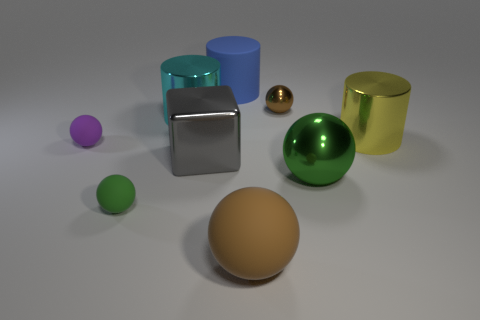Subtract 1 spheres. How many spheres are left? 4 Subtract all purple balls. How many balls are left? 4 Subtract all large green shiny spheres. How many spheres are left? 4 Subtract all purple balls. Subtract all yellow cylinders. How many balls are left? 4 Subtract all spheres. How many objects are left? 4 Add 6 tiny red balls. How many tiny red balls exist? 6 Subtract 0 red balls. How many objects are left? 9 Subtract all large cyan shiny cylinders. Subtract all brown rubber things. How many objects are left? 7 Add 9 big yellow things. How many big yellow things are left? 10 